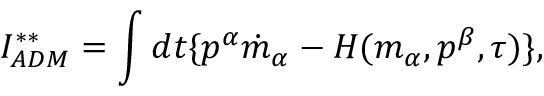Convert formula to latex. <formula><loc_0><loc_0><loc_500><loc_500>I _ { A D M } ^ { \ast \ast } = \int d t \{ p ^ { \alpha } \dot { m } _ { \alpha } - H ( m _ { \alpha } , p ^ { \beta } , \tau ) \} ,</formula> 